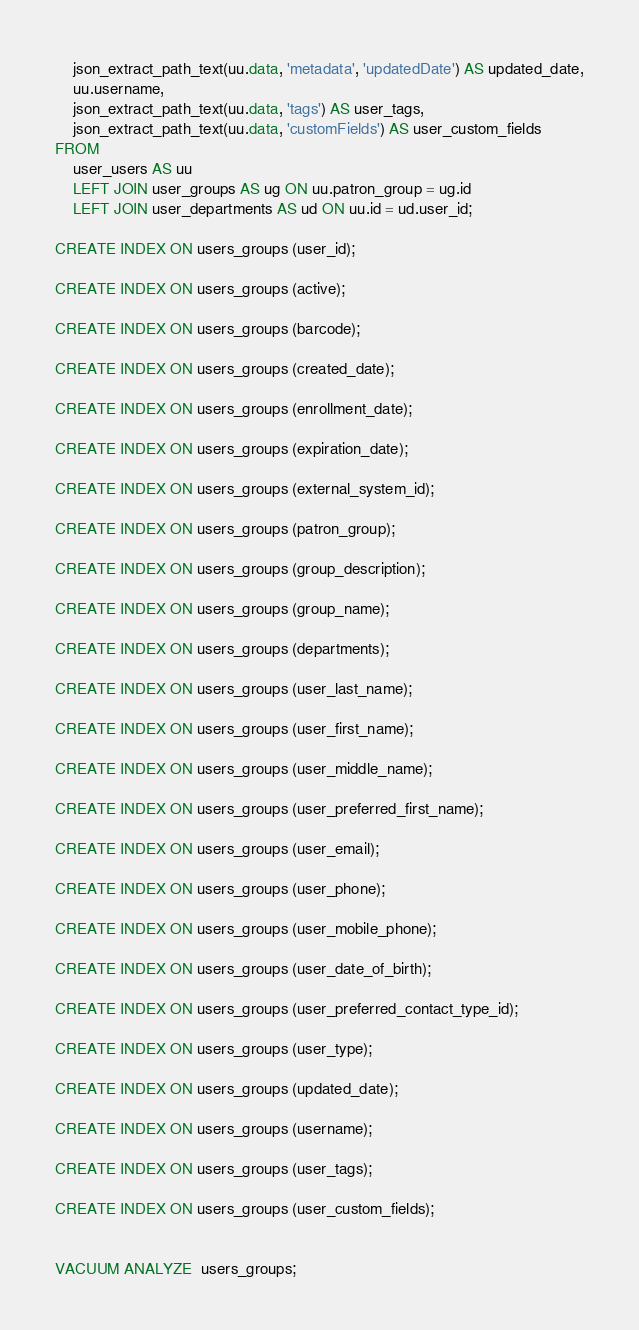<code> <loc_0><loc_0><loc_500><loc_500><_SQL_>    json_extract_path_text(uu.data, 'metadata', 'updatedDate') AS updated_date,
    uu.username,
    json_extract_path_text(uu.data, 'tags') AS user_tags,
    json_extract_path_text(uu.data, 'customFields') AS user_custom_fields
FROM
    user_users AS uu
    LEFT JOIN user_groups AS ug ON uu.patron_group = ug.id
    LEFT JOIN user_departments AS ud ON uu.id = ud.user_id;

CREATE INDEX ON users_groups (user_id);

CREATE INDEX ON users_groups (active);

CREATE INDEX ON users_groups (barcode);

CREATE INDEX ON users_groups (created_date);

CREATE INDEX ON users_groups (enrollment_date);

CREATE INDEX ON users_groups (expiration_date);

CREATE INDEX ON users_groups (external_system_id);

CREATE INDEX ON users_groups (patron_group);

CREATE INDEX ON users_groups (group_description);

CREATE INDEX ON users_groups (group_name);

CREATE INDEX ON users_groups (departments);

CREATE INDEX ON users_groups (user_last_name);

CREATE INDEX ON users_groups (user_first_name);

CREATE INDEX ON users_groups (user_middle_name);

CREATE INDEX ON users_groups (user_preferred_first_name);

CREATE INDEX ON users_groups (user_email);

CREATE INDEX ON users_groups (user_phone);

CREATE INDEX ON users_groups (user_mobile_phone);

CREATE INDEX ON users_groups (user_date_of_birth);

CREATE INDEX ON users_groups (user_preferred_contact_type_id);

CREATE INDEX ON users_groups (user_type);

CREATE INDEX ON users_groups (updated_date);

CREATE INDEX ON users_groups (username);

CREATE INDEX ON users_groups (user_tags);

CREATE INDEX ON users_groups (user_custom_fields);


VACUUM ANALYZE  users_groups;
</code> 